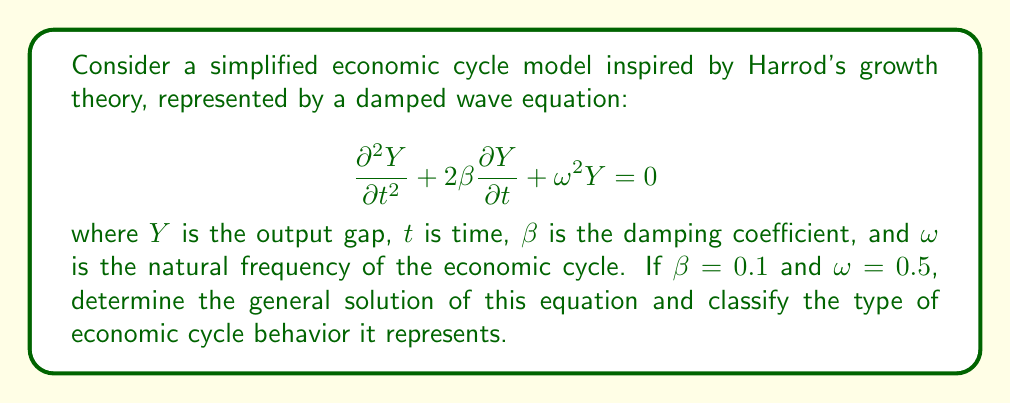Provide a solution to this math problem. Let's solve this step-by-step:

1) The characteristic equation for this damped wave equation is:
   $$r^2 + 2\beta r + \omega^2 = 0$$

2) Substituting the given values:
   $$r^2 + 0.2r + 0.25 = 0$$

3) Using the quadratic formula, $r = \frac{-b \pm \sqrt{b^2 - 4ac}}{2a}$:
   $$r = \frac{-0.2 \pm \sqrt{0.04 - 1}}{2} = -0.1 \pm \sqrt{-0.24}$$

4) This gives us complex roots:
   $$r = -0.1 \pm 0.49i$$

5) The general solution for complex roots is:
   $$Y(t) = e^{-\beta t}(A\cos(\omega_d t) + B\sin(\omega_d t))$$
   where $\omega_d = \sqrt{\omega^2 - \beta^2}$

6) Calculating $\omega_d$:
   $$\omega_d = \sqrt{0.5^2 - 0.1^2} = \sqrt{0.24} \approx 0.49$$

7) Therefore, the general solution is:
   $$Y(t) = e^{-0.1t}(A\cos(0.49t) + B\sin(0.49t))$$

8) This represents underdamped oscillations. In economic terms, this indicates cycles that gradually decrease in amplitude over time but continue to oscillate.
Answer: $Y(t) = e^{-0.1t}(A\cos(0.49t) + B\sin(0.49t))$; Underdamped oscillations 